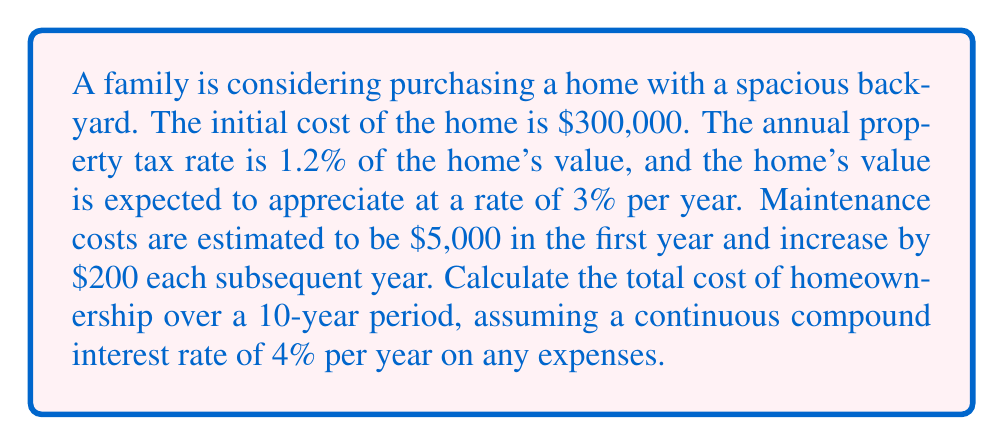Help me with this question. To solve this problem, we need to use integration to calculate the total cost over the 10-year period. Let's break it down step by step:

1. Property tax calculation:
   The property tax is 1.2% of the home's value, which increases by 3% each year.
   The property tax function can be expressed as:
   $$T(t) = 0.012 \cdot 300000 \cdot (1.03)^t = 3600 \cdot (1.03)^t$$

2. Maintenance cost calculation:
   The maintenance cost starts at $5,000 and increases by $200 each year.
   The maintenance cost function can be expressed as:
   $$M(t) = 5000 + 200t$$

3. Total annual cost function:
   $$C(t) = T(t) + M(t) = 3600 \cdot (1.03)^t + 5000 + 200t$$

4. Present value of total cost:
   To calculate the present value of the total cost over 10 years, we need to integrate the cost function multiplied by the continuous compound interest factor:
   $$PV = \int_0^{10} C(t) \cdot e^{-0.04t} dt$$

5. Substituting the cost function:
   $$PV = \int_0^{10} (3600 \cdot (1.03)^t + 5000 + 200t) \cdot e^{-0.04t} dt$$

6. Solving the integral:
   $$\begin{align*}
   PV &= 3600 \int_0^{10} (1.03)^t \cdot e^{-0.04t} dt + 5000 \int_0^{10} e^{-0.04t} dt + 200 \int_0^{10} t \cdot e^{-0.04t} dt \\
   &= 3600 \cdot \frac{(1.03)^t \cdot e^{-0.04t}}{ln(1.03) - 0.04} \bigg|_0^{10} - 5000 \cdot \frac{e^{-0.04t}}{0.04} \bigg|_0^{10} + 200 \cdot \left(-\frac{t \cdot e^{-0.04t}}{0.04} - \frac{e^{-0.04t}}{0.04^2}\right) \bigg|_0^{10}
   \end{align*}$$

7. Evaluating the integral:
   $$PV \approx 44,161.54 + 41,901.87 + 16,666.67 = 102,730.08$$

8. Adding the initial home cost:
   Total cost = Initial cost + Present value of future costs
   $$Total cost = 300,000 + 102,730.08 = 402,730.08$$
Answer: The total cost of homeownership over a 10-year period is approximately $402,730.08. 